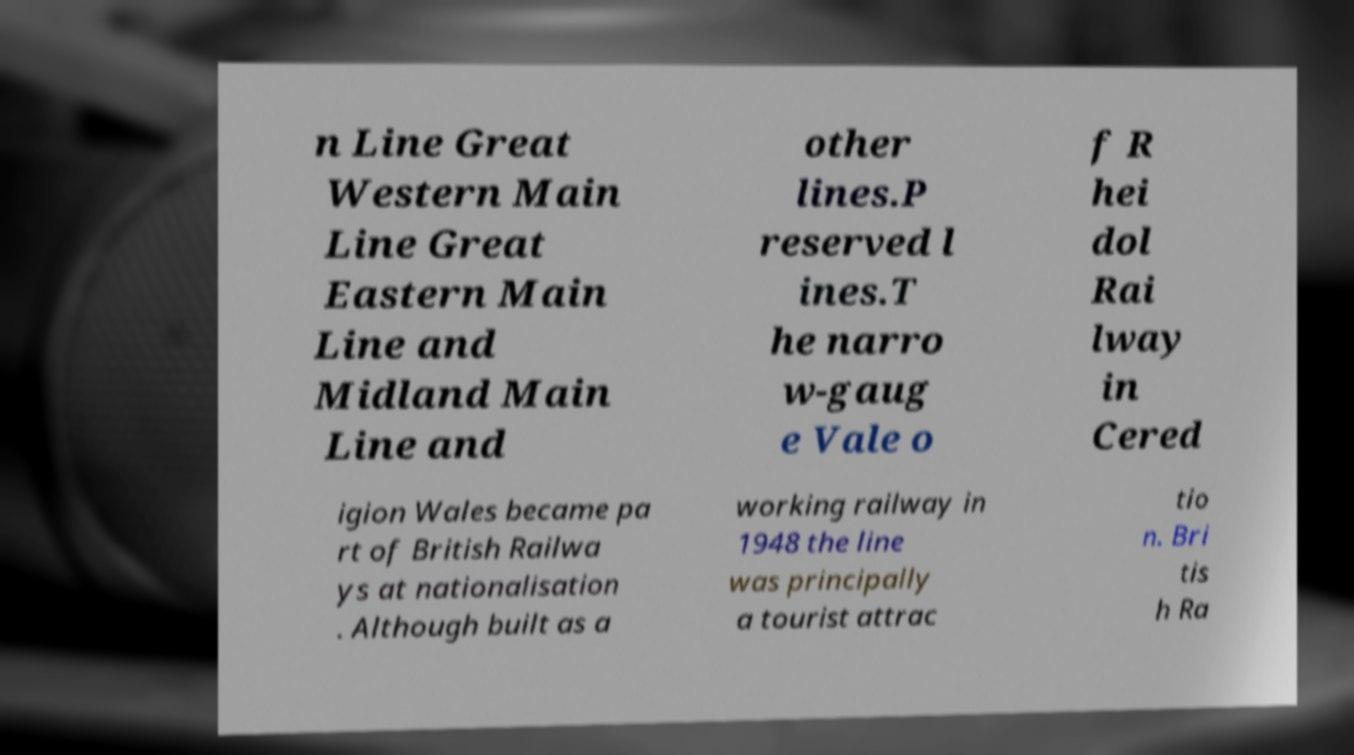I need the written content from this picture converted into text. Can you do that? n Line Great Western Main Line Great Eastern Main Line and Midland Main Line and other lines.P reserved l ines.T he narro w-gaug e Vale o f R hei dol Rai lway in Cered igion Wales became pa rt of British Railwa ys at nationalisation . Although built as a working railway in 1948 the line was principally a tourist attrac tio n. Bri tis h Ra 